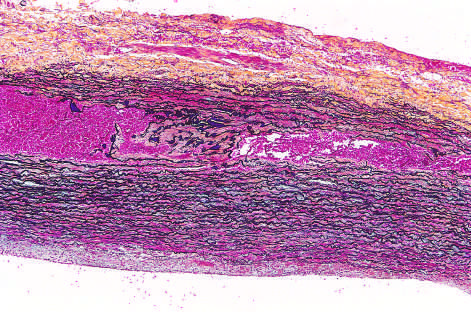s blood red in this section, stained with movat stain?
Answer the question using a single word or phrase. Yes 